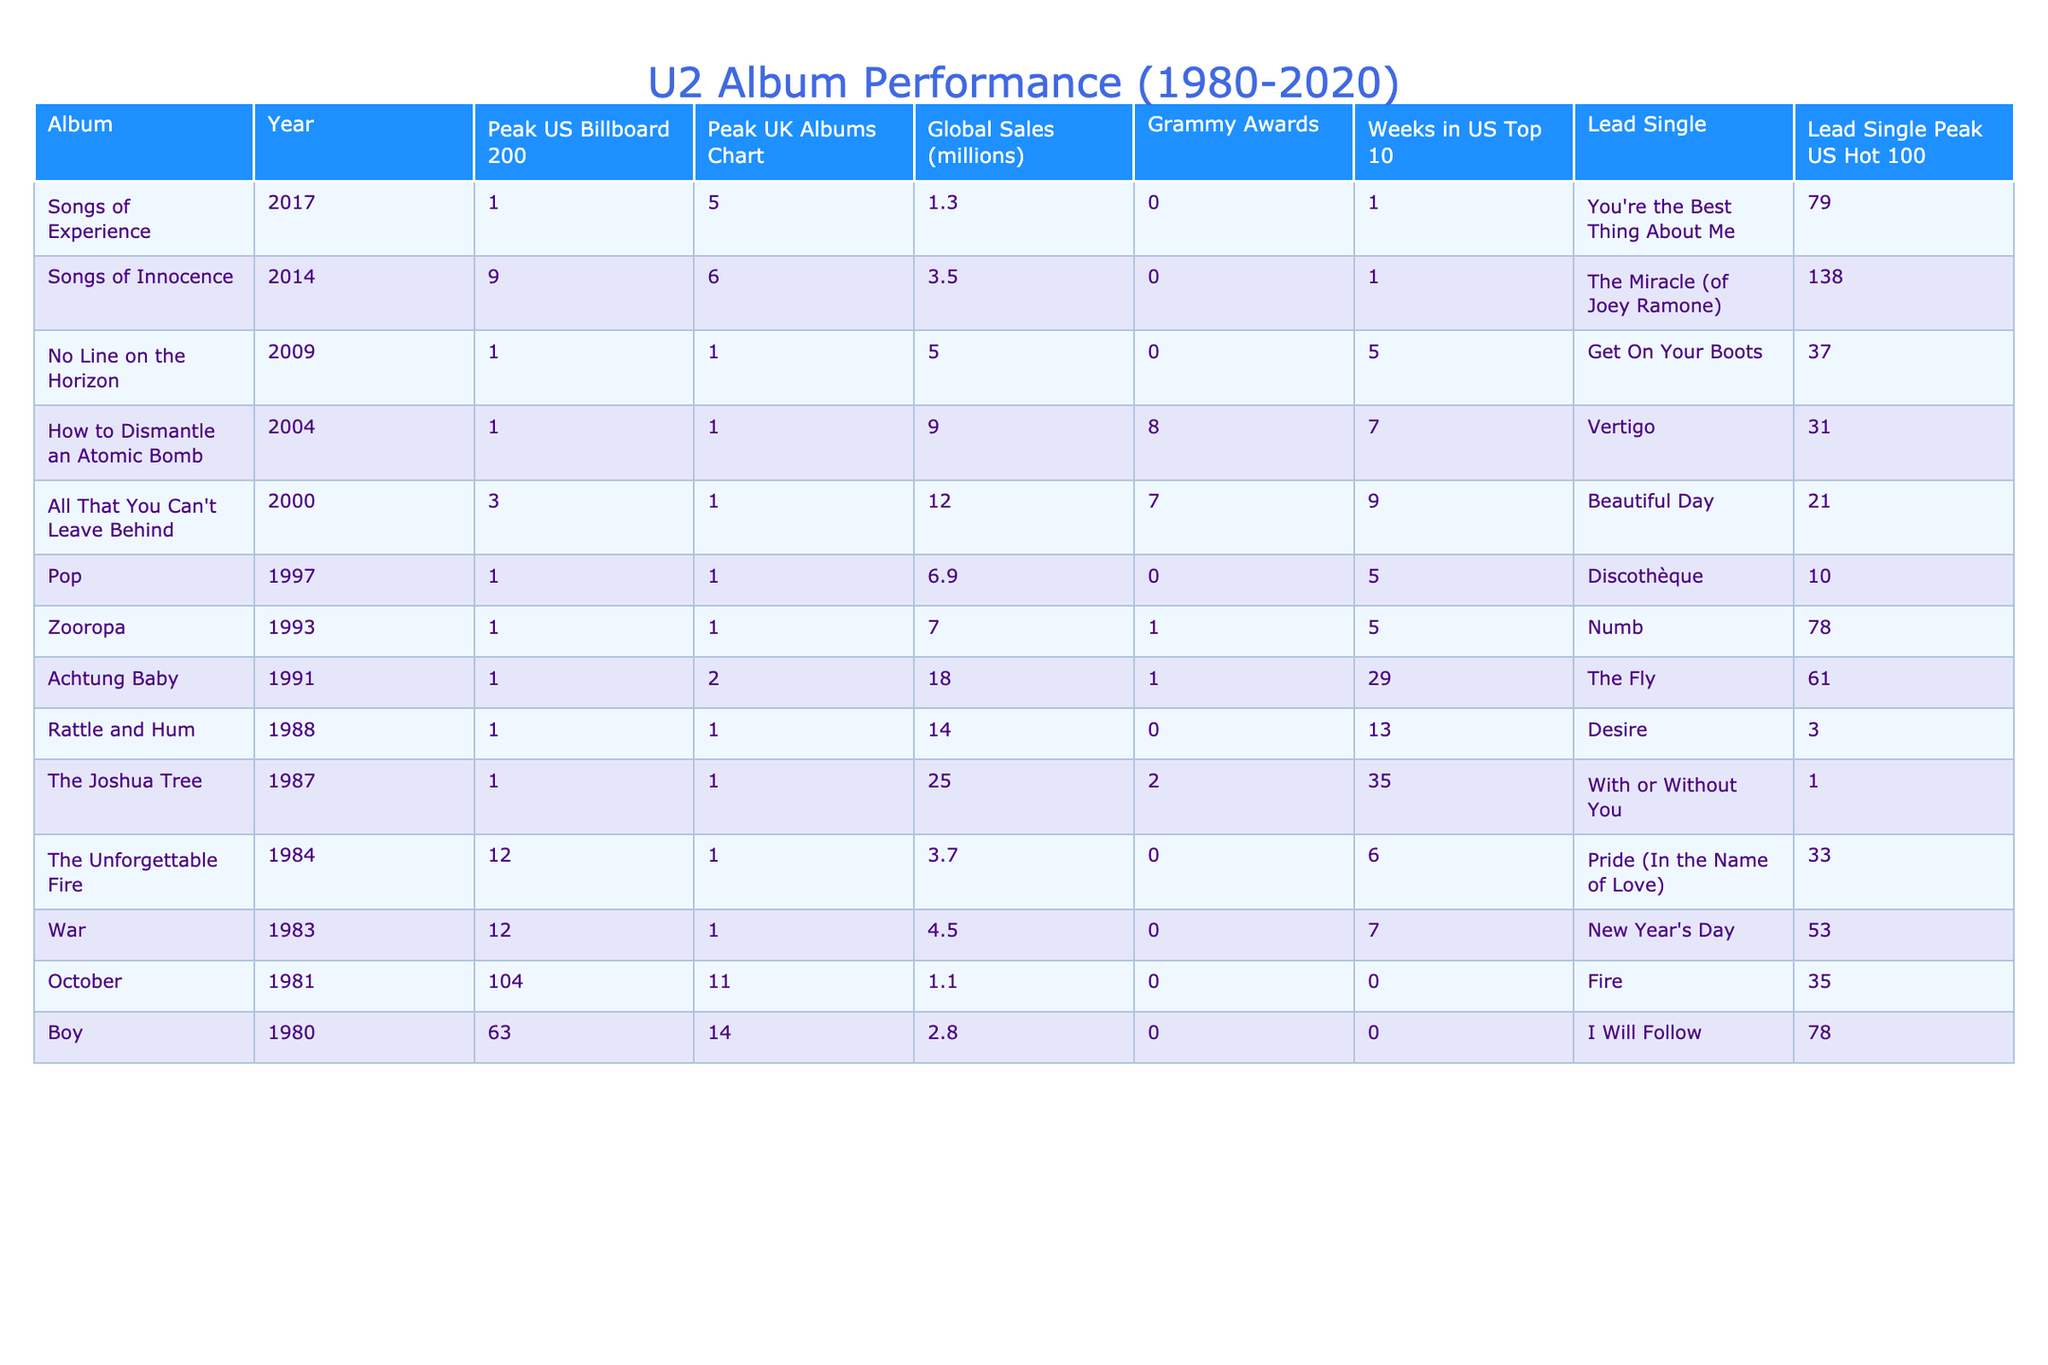What was the highest peak position achieved by any U2 album on the US Billboard 200? The highest peak position on the US Billboard 200 is 1, reached by multiple albums such as "The Joshua Tree," "Rattle and Hum," "Achtung Baby," "Zooropa," "Pop," "How to Dismantle an Atomic Bomb," and "No Line on the Horizon."
Answer: 1 Which U2 album had the most weeks in the US Top 10? Among the listed albums, "The Joshua Tree" had the most weeks in the US Top 10, totaling 35 weeks.
Answer: 35 weeks Did U2 win any Grammy awards for their album "All That You Can't Leave Behind"? Yes, U2 won 7 Grammy awards for their album "All That You Can't Leave Behind."
Answer: Yes What was the global sales of "Achtung Baby"? "Achtung Baby" sold 18 million copies globally.
Answer: 18 million Which album had the peak UK Albums Chart position of 5? "Songs of Experience" had a peak UK Albums Chart position of 5.
Answer: Songs of Experience What is the difference in global sales between "War" and "No Line on the Horizon"? "War" sold 4.5 million and "No Line on the Horizon" sold 5 million; the difference is 5 - 4.5 = 0.5 million.
Answer: 0.5 million Which album is associated with the lead single "Vertigo"? "How to Dismantle an Atomic Bomb" is associated with the lead single "Vertigo."
Answer: How to Dismantle an Atomic Bomb Which U2 album released in 2000 had the highest number of Grammy awards? "All That You Can't Leave Behind," released in 2000, had the highest number of Grammy awards with 7.
Answer: All That You Can't Leave Behind How many albums reached the peak position of 1 on both US Billboard 200 and UK Albums Chart? Four albums ("The Joshua Tree," "Rattle and Hum," "Achtung Baby," and "How to Dismantle an Atomic Bomb") reached the peak position of 1 on both charts.
Answer: 4 What is the average global sales of U2 albums released between 1990 and 2000? The global sales for these albums ("Achtung Baby," "Zooropa," "Pop," and "All That You Can't Leave Behind") total 43.9 million. Dividing by 4 gives an average of 10.975 million.
Answer: 10.975 million 